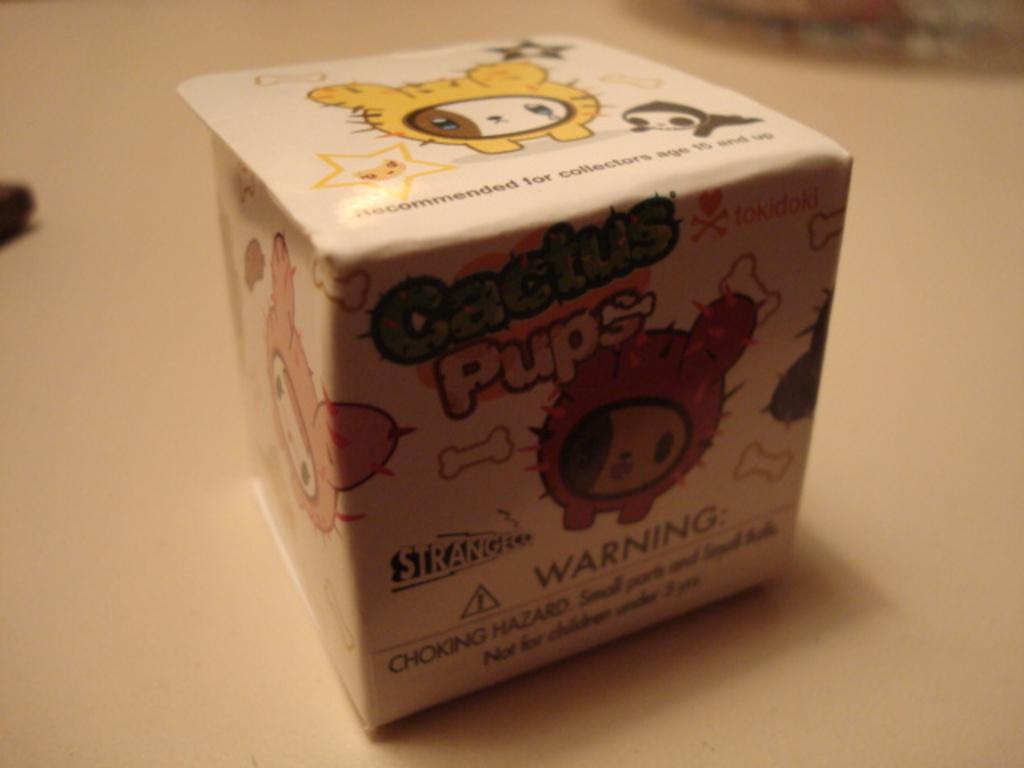What is this toy warning us on?
Provide a succinct answer. Choking hazard. What is the name of the toy?
Offer a terse response. Cactus pups. 